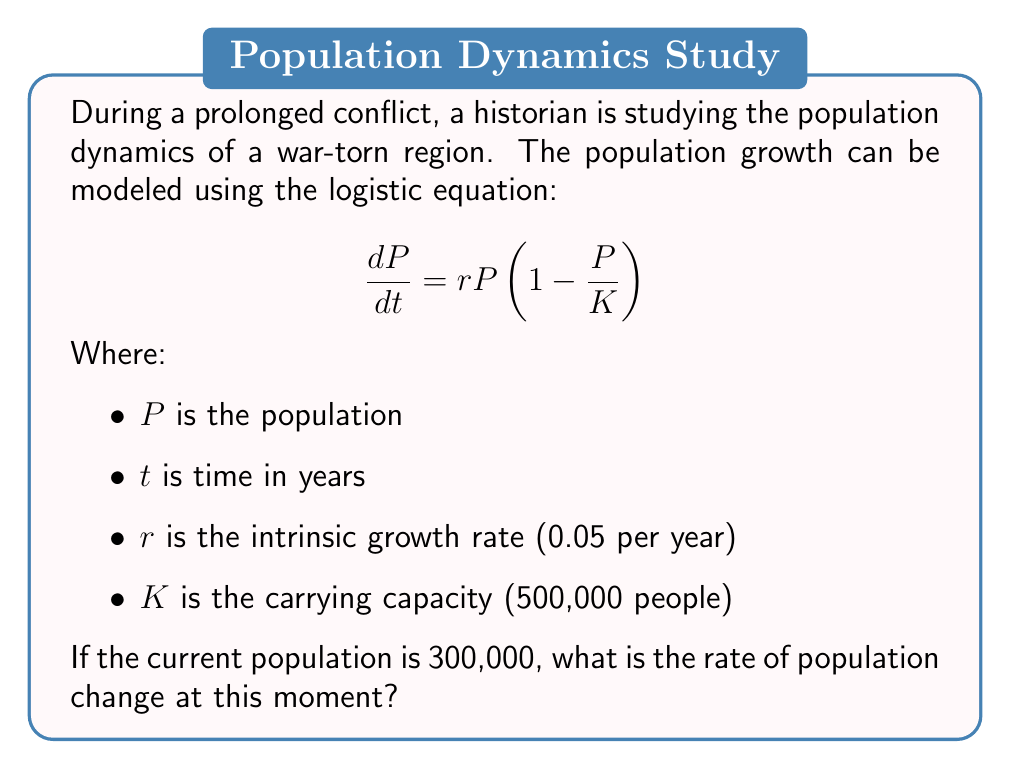What is the answer to this math problem? To solve this problem, we'll follow these steps:

1) We have the logistic growth equation:
   $$\frac{dP}{dt} = rP(1 - \frac{P}{K})$$

2) We're given the following values:
   $r = 0.05$ per year
   $K = 500,000$ people
   $P = 300,000$ people (current population)

3) Let's substitute these values into the equation:
   $$\frac{dP}{dt} = 0.05 \cdot 300,000 \cdot (1 - \frac{300,000}{500,000})$$

4) Simplify the fraction inside the parentheses:
   $$\frac{dP}{dt} = 0.05 \cdot 300,000 \cdot (1 - 0.6)$$

5) Simplify further:
   $$\frac{dP}{dt} = 0.05 \cdot 300,000 \cdot 0.4$$

6) Calculate the result:
   $$\frac{dP}{dt} = 15,000 \cdot 0.4 = 6,000$$

Therefore, the rate of population change at this moment is 6,000 people per year.
Answer: 6,000 people per year 